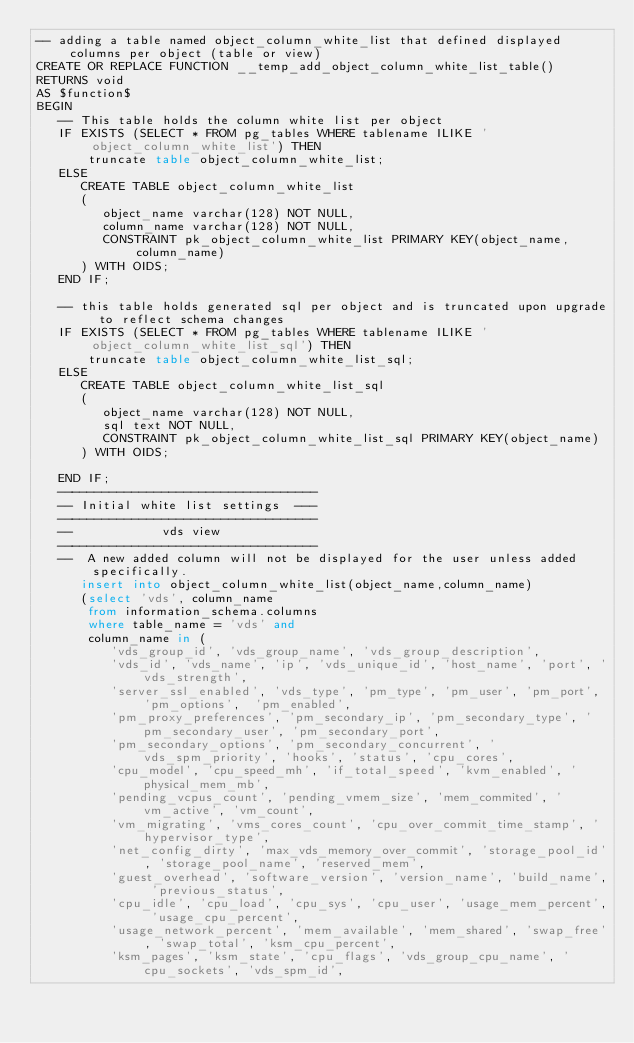<code> <loc_0><loc_0><loc_500><loc_500><_SQL_>-- adding a table named object_column_white_list that defined displayed columns per object (table or view)
CREATE OR REPLACE FUNCTION __temp_add_object_column_white_list_table()
RETURNS void
AS $function$
BEGIN
   -- This table holds the column white list per object
   IF EXISTS (SELECT * FROM pg_tables WHERE tablename ILIKE 'object_column_white_list') THEN
       truncate table object_column_white_list;
   ELSE
      CREATE TABLE object_column_white_list
      (
         object_name varchar(128) NOT NULL,
         column_name varchar(128) NOT NULL,
         CONSTRAINT pk_object_column_white_list PRIMARY KEY(object_name,column_name)
      ) WITH OIDS;
   END IF;

   -- this table holds generated sql per object and is truncated upon upgrade to reflect schema changes
   IF EXISTS (SELECT * FROM pg_tables WHERE tablename ILIKE 'object_column_white_list_sql') THEN
       truncate table object_column_white_list_sql;
   ELSE
      CREATE TABLE object_column_white_list_sql
      (
         object_name varchar(128) NOT NULL,
         sql text NOT NULL,
         CONSTRAINT pk_object_column_white_list_sql PRIMARY KEY(object_name)
      ) WITH OIDS;

   END IF;
   -----------------------------------
   -- Initial white list settings  ---
   -----------------------------------
   --            vds view
   -----------------------------------
   --  A new added column will not be displayed for the user unless added specifically.
      insert into object_column_white_list(object_name,column_name)
      (select 'vds', column_name
       from information_schema.columns
       where table_name = 'vds' and
       column_name in (
          'vds_group_id', 'vds_group_name', 'vds_group_description',
          'vds_id', 'vds_name', 'ip', 'vds_unique_id', 'host_name', 'port', 'vds_strength',
          'server_ssl_enabled', 'vds_type', 'pm_type', 'pm_user', 'pm_port', 'pm_options',  'pm_enabled',
          'pm_proxy_preferences', 'pm_secondary_ip', 'pm_secondary_type', 'pm_secondary_user', 'pm_secondary_port',
          'pm_secondary_options', 'pm_secondary_concurrent', 'vds_spm_priority', 'hooks', 'status', 'cpu_cores',
          'cpu_model', 'cpu_speed_mh', 'if_total_speed', 'kvm_enabled', 'physical_mem_mb',
          'pending_vcpus_count', 'pending_vmem_size', 'mem_commited', 'vm_active', 'vm_count',
          'vm_migrating', 'vms_cores_count', 'cpu_over_commit_time_stamp', 'hypervisor_type',
          'net_config_dirty', 'max_vds_memory_over_commit', 'storage_pool_id', 'storage_pool_name', 'reserved_mem',
          'guest_overhead', 'software_version', 'version_name', 'build_name', 'previous_status',
          'cpu_idle', 'cpu_load', 'cpu_sys', 'cpu_user', 'usage_mem_percent', 'usage_cpu_percent',
          'usage_network_percent', 'mem_available', 'mem_shared', 'swap_free', 'swap_total', 'ksm_cpu_percent',
          'ksm_pages', 'ksm_state', 'cpu_flags', 'vds_group_cpu_name', 'cpu_sockets', 'vds_spm_id',</code> 